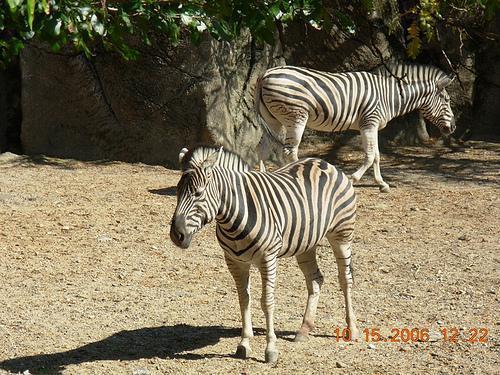How many zebras are in the image?
Give a very brief answer. 2. How many zebras are there?
Give a very brief answer. 2. How many zebra feet are there?
Give a very brief answer. 8. How many zebras can be seen?
Give a very brief answer. 2. How many orange slices are there?
Give a very brief answer. 0. 